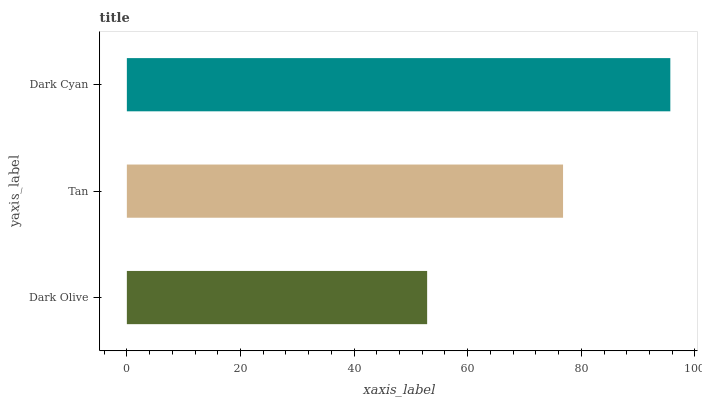Is Dark Olive the minimum?
Answer yes or no. Yes. Is Dark Cyan the maximum?
Answer yes or no. Yes. Is Tan the minimum?
Answer yes or no. No. Is Tan the maximum?
Answer yes or no. No. Is Tan greater than Dark Olive?
Answer yes or no. Yes. Is Dark Olive less than Tan?
Answer yes or no. Yes. Is Dark Olive greater than Tan?
Answer yes or no. No. Is Tan less than Dark Olive?
Answer yes or no. No. Is Tan the high median?
Answer yes or no. Yes. Is Tan the low median?
Answer yes or no. Yes. Is Dark Olive the high median?
Answer yes or no. No. Is Dark Cyan the low median?
Answer yes or no. No. 